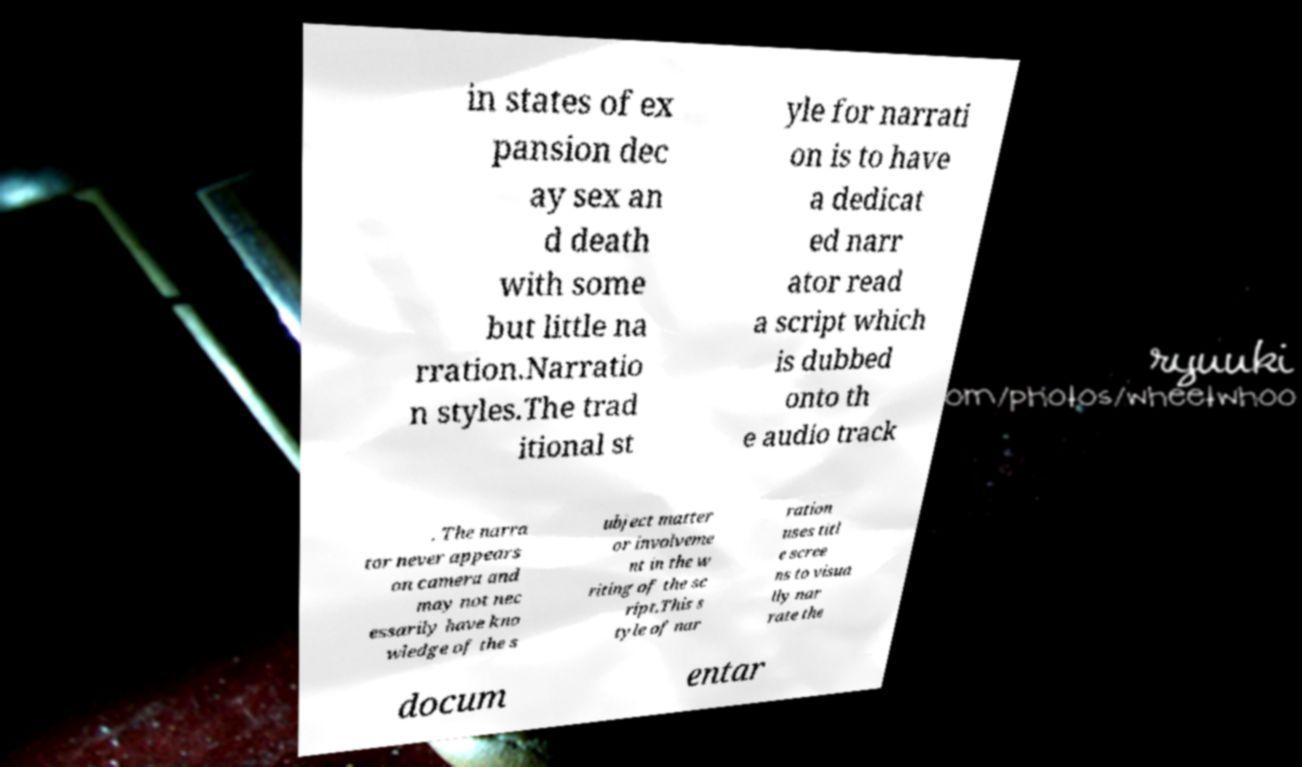Please identify and transcribe the text found in this image. in states of ex pansion dec ay sex an d death with some but little na rration.Narratio n styles.The trad itional st yle for narrati on is to have a dedicat ed narr ator read a script which is dubbed onto th e audio track . The narra tor never appears on camera and may not nec essarily have kno wledge of the s ubject matter or involveme nt in the w riting of the sc ript.This s tyle of nar ration uses titl e scree ns to visua lly nar rate the docum entar 